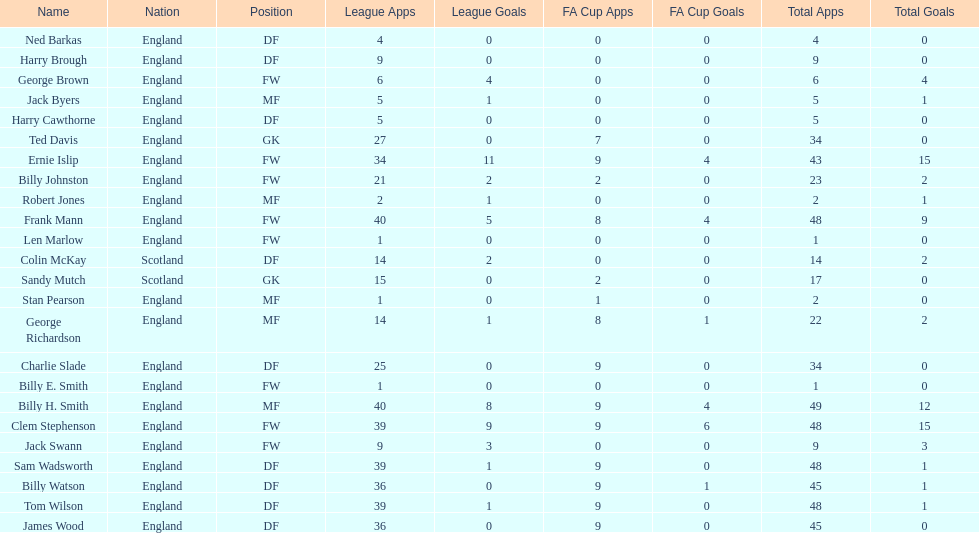What is the number of players classified as fws? 8. 